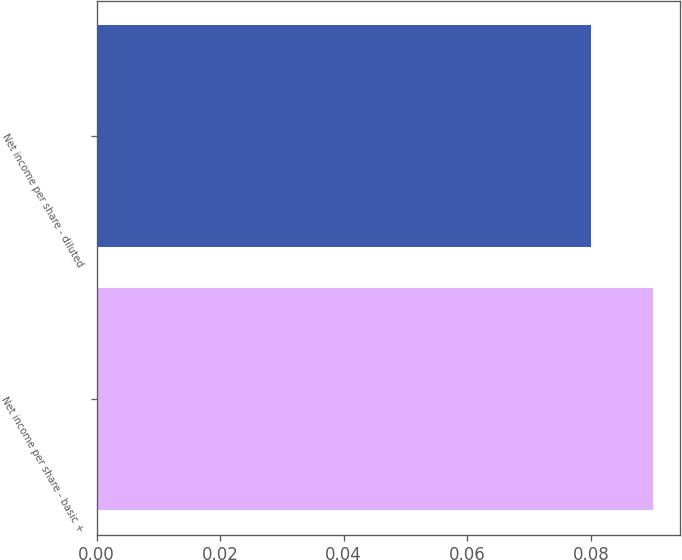Convert chart to OTSL. <chart><loc_0><loc_0><loc_500><loc_500><bar_chart><fcel>Net income per share - basic +<fcel>Net income per share - diluted<nl><fcel>0.09<fcel>0.08<nl></chart> 